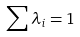<formula> <loc_0><loc_0><loc_500><loc_500>\sum \lambda _ { i } = 1</formula> 